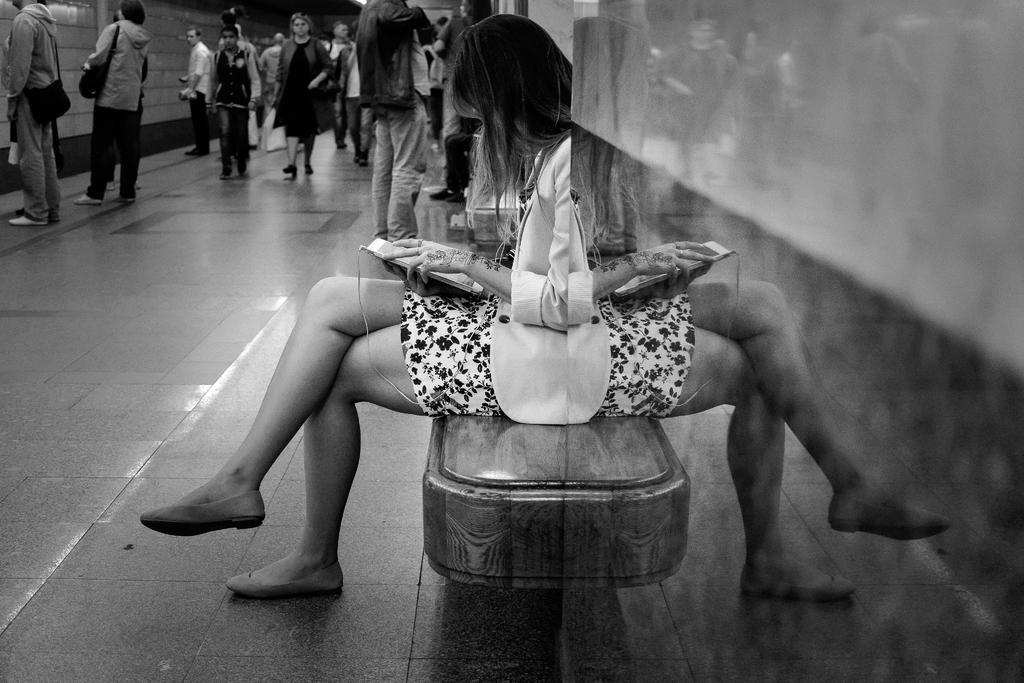Please provide a concise description of this image. This picture describes about group of people, few are standing and few are walking, in the middle of the image we can see a woman, she is seated and she is holding a mobile, it is a black and white photograph. 